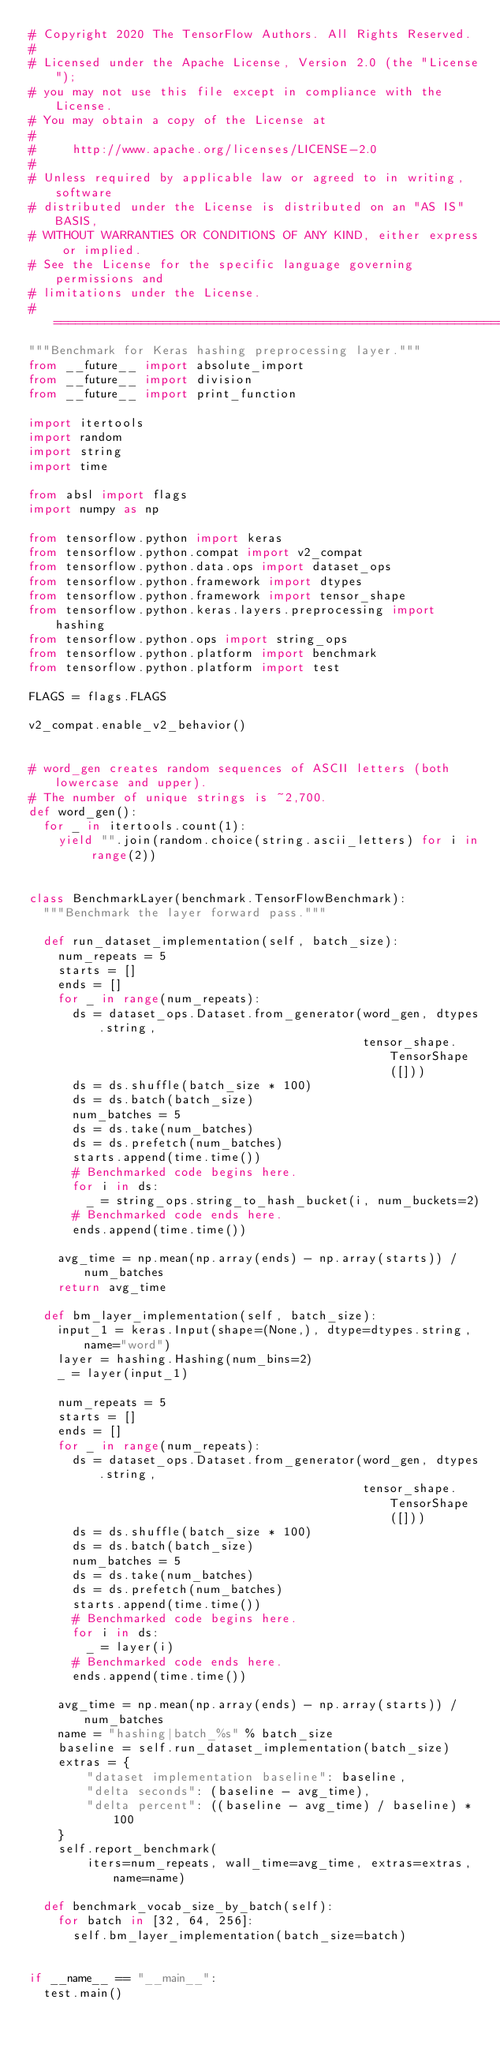Convert code to text. <code><loc_0><loc_0><loc_500><loc_500><_Python_># Copyright 2020 The TensorFlow Authors. All Rights Reserved.
#
# Licensed under the Apache License, Version 2.0 (the "License");
# you may not use this file except in compliance with the License.
# You may obtain a copy of the License at
#
#     http://www.apache.org/licenses/LICENSE-2.0
#
# Unless required by applicable law or agreed to in writing, software
# distributed under the License is distributed on an "AS IS" BASIS,
# WITHOUT WARRANTIES OR CONDITIONS OF ANY KIND, either express or implied.
# See the License for the specific language governing permissions and
# limitations under the License.
# ==============================================================================
"""Benchmark for Keras hashing preprocessing layer."""
from __future__ import absolute_import
from __future__ import division
from __future__ import print_function

import itertools
import random
import string
import time

from absl import flags
import numpy as np

from tensorflow.python import keras
from tensorflow.python.compat import v2_compat
from tensorflow.python.data.ops import dataset_ops
from tensorflow.python.framework import dtypes
from tensorflow.python.framework import tensor_shape
from tensorflow.python.keras.layers.preprocessing import hashing
from tensorflow.python.ops import string_ops
from tensorflow.python.platform import benchmark
from tensorflow.python.platform import test

FLAGS = flags.FLAGS

v2_compat.enable_v2_behavior()


# word_gen creates random sequences of ASCII letters (both lowercase and upper).
# The number of unique strings is ~2,700.
def word_gen():
  for _ in itertools.count(1):
    yield "".join(random.choice(string.ascii_letters) for i in range(2))


class BenchmarkLayer(benchmark.TensorFlowBenchmark):
  """Benchmark the layer forward pass."""

  def run_dataset_implementation(self, batch_size):
    num_repeats = 5
    starts = []
    ends = []
    for _ in range(num_repeats):
      ds = dataset_ops.Dataset.from_generator(word_gen, dtypes.string,
                                              tensor_shape.TensorShape([]))
      ds = ds.shuffle(batch_size * 100)
      ds = ds.batch(batch_size)
      num_batches = 5
      ds = ds.take(num_batches)
      ds = ds.prefetch(num_batches)
      starts.append(time.time())
      # Benchmarked code begins here.
      for i in ds:
        _ = string_ops.string_to_hash_bucket(i, num_buckets=2)
      # Benchmarked code ends here.
      ends.append(time.time())

    avg_time = np.mean(np.array(ends) - np.array(starts)) / num_batches
    return avg_time

  def bm_layer_implementation(self, batch_size):
    input_1 = keras.Input(shape=(None,), dtype=dtypes.string, name="word")
    layer = hashing.Hashing(num_bins=2)
    _ = layer(input_1)

    num_repeats = 5
    starts = []
    ends = []
    for _ in range(num_repeats):
      ds = dataset_ops.Dataset.from_generator(word_gen, dtypes.string,
                                              tensor_shape.TensorShape([]))
      ds = ds.shuffle(batch_size * 100)
      ds = ds.batch(batch_size)
      num_batches = 5
      ds = ds.take(num_batches)
      ds = ds.prefetch(num_batches)
      starts.append(time.time())
      # Benchmarked code begins here.
      for i in ds:
        _ = layer(i)
      # Benchmarked code ends here.
      ends.append(time.time())

    avg_time = np.mean(np.array(ends) - np.array(starts)) / num_batches
    name = "hashing|batch_%s" % batch_size
    baseline = self.run_dataset_implementation(batch_size)
    extras = {
        "dataset implementation baseline": baseline,
        "delta seconds": (baseline - avg_time),
        "delta percent": ((baseline - avg_time) / baseline) * 100
    }
    self.report_benchmark(
        iters=num_repeats, wall_time=avg_time, extras=extras, name=name)

  def benchmark_vocab_size_by_batch(self):
    for batch in [32, 64, 256]:
      self.bm_layer_implementation(batch_size=batch)


if __name__ == "__main__":
  test.main()
</code> 